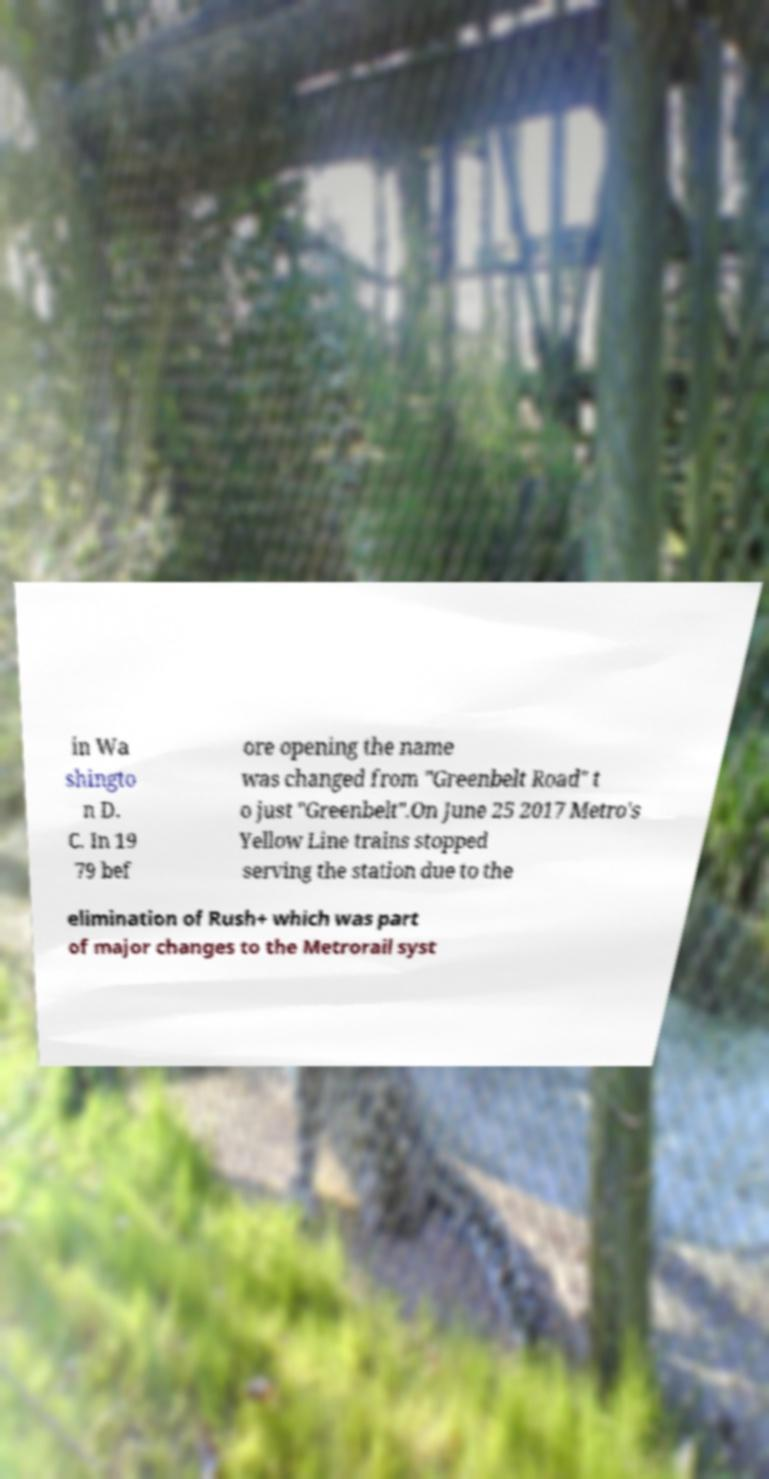Please identify and transcribe the text found in this image. in Wa shingto n D. C. In 19 79 bef ore opening the name was changed from "Greenbelt Road" t o just "Greenbelt".On June 25 2017 Metro's Yellow Line trains stopped serving the station due to the elimination of Rush+ which was part of major changes to the Metrorail syst 